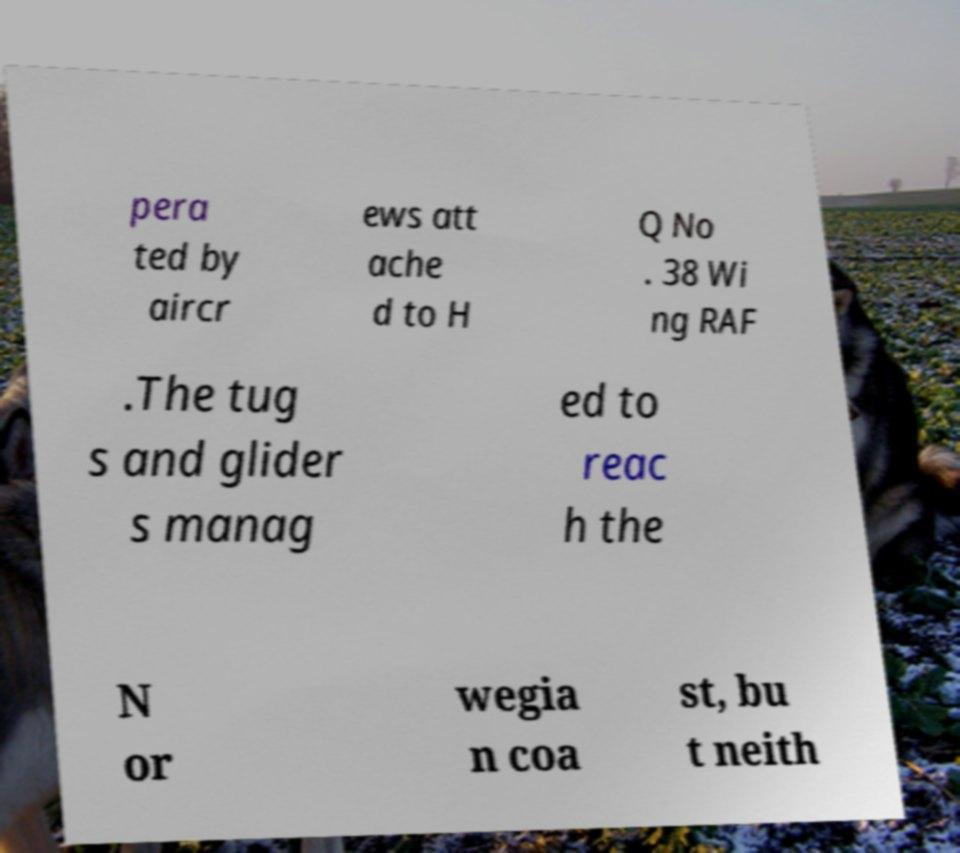I need the written content from this picture converted into text. Can you do that? pera ted by aircr ews att ache d to H Q No . 38 Wi ng RAF .The tug s and glider s manag ed to reac h the N or wegia n coa st, bu t neith 